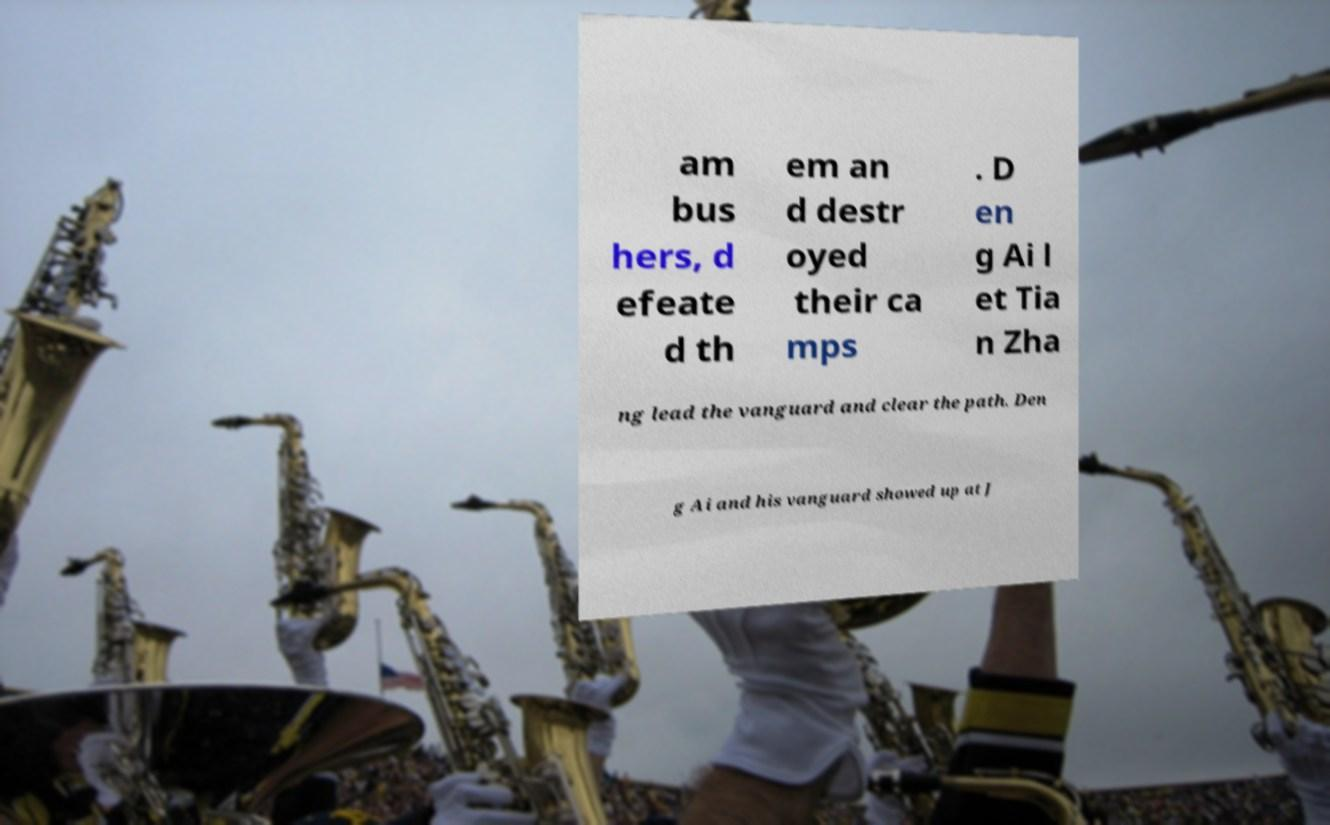Could you extract and type out the text from this image? am bus hers, d efeate d th em an d destr oyed their ca mps . D en g Ai l et Tia n Zha ng lead the vanguard and clear the path. Den g Ai and his vanguard showed up at J 